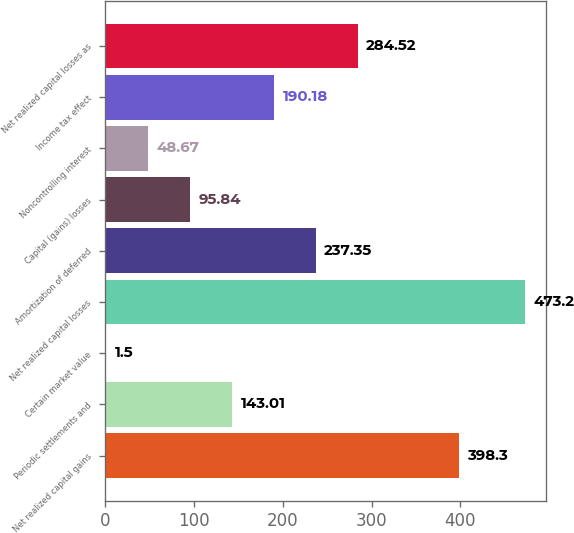Convert chart. <chart><loc_0><loc_0><loc_500><loc_500><bar_chart><fcel>Net realized capital gains<fcel>Periodic settlements and<fcel>Certain market value<fcel>Net realized capital losses<fcel>Amortization of deferred<fcel>Capital (gains) losses<fcel>Noncontrolling interest<fcel>Income tax effect<fcel>Net realized capital losses as<nl><fcel>398.3<fcel>143.01<fcel>1.5<fcel>473.2<fcel>237.35<fcel>95.84<fcel>48.67<fcel>190.18<fcel>284.52<nl></chart> 